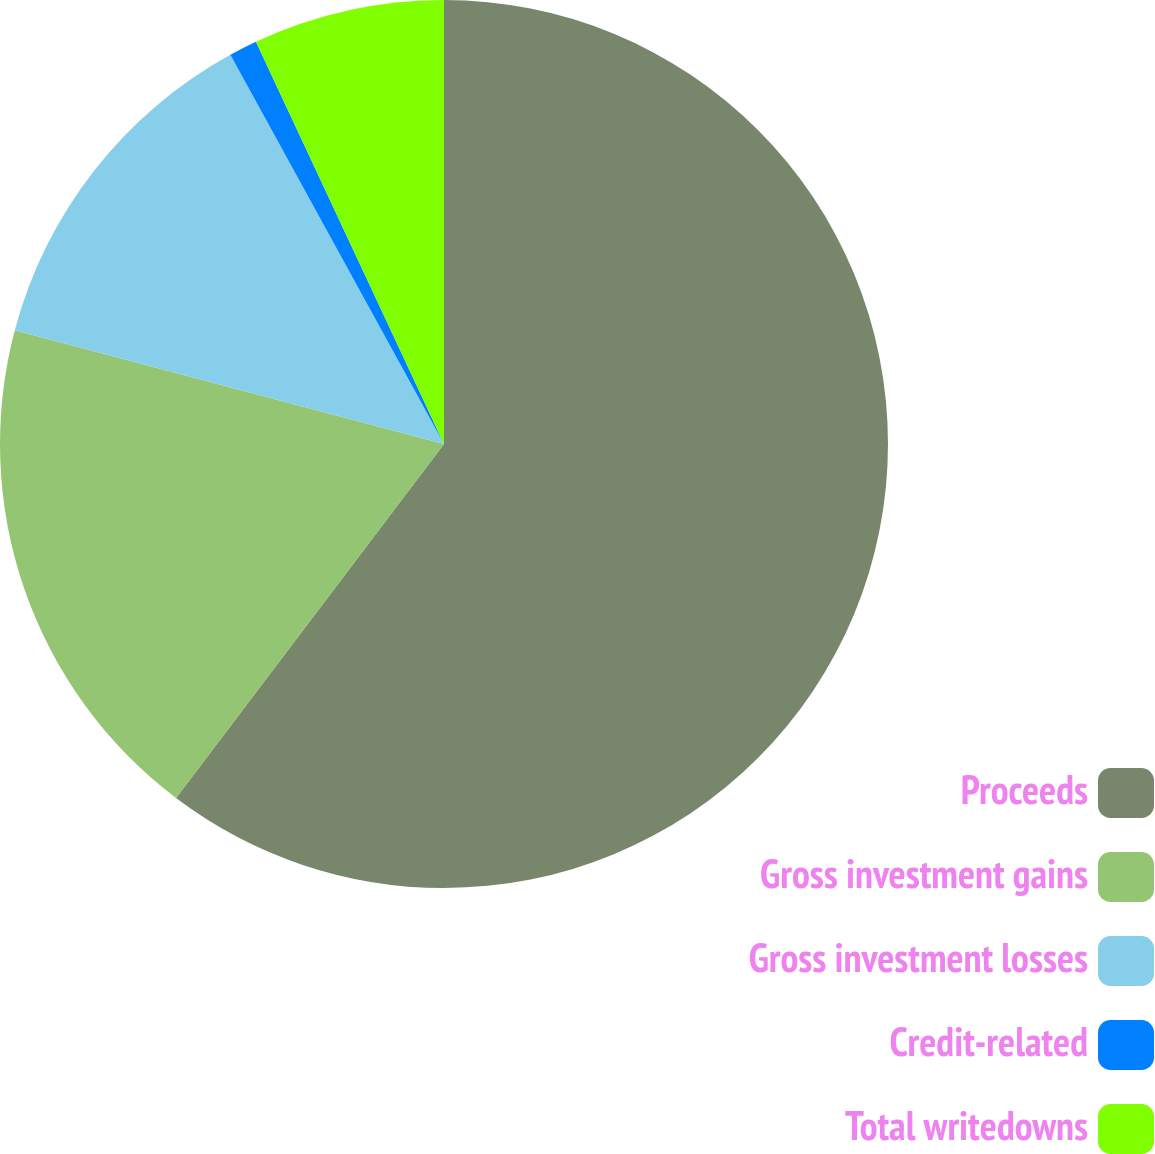<chart> <loc_0><loc_0><loc_500><loc_500><pie_chart><fcel>Proceeds<fcel>Gross investment gains<fcel>Gross investment losses<fcel>Credit-related<fcel>Total writedowns<nl><fcel>60.31%<fcel>18.81%<fcel>12.89%<fcel>1.03%<fcel>6.96%<nl></chart> 